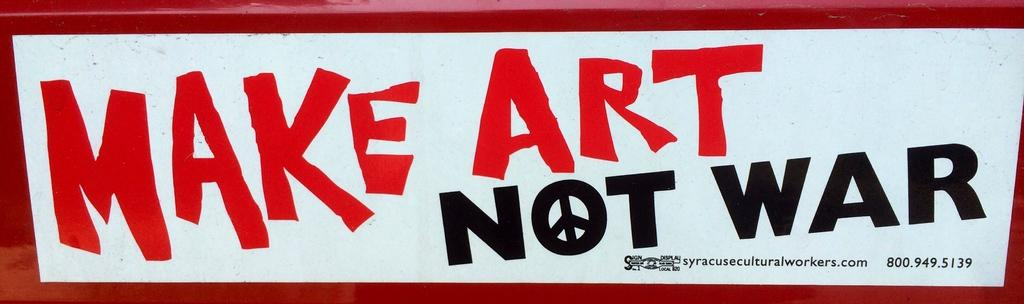<image>
Render a clear and concise summary of the photo. A bumper sticker that reads make art not war with a white background. 